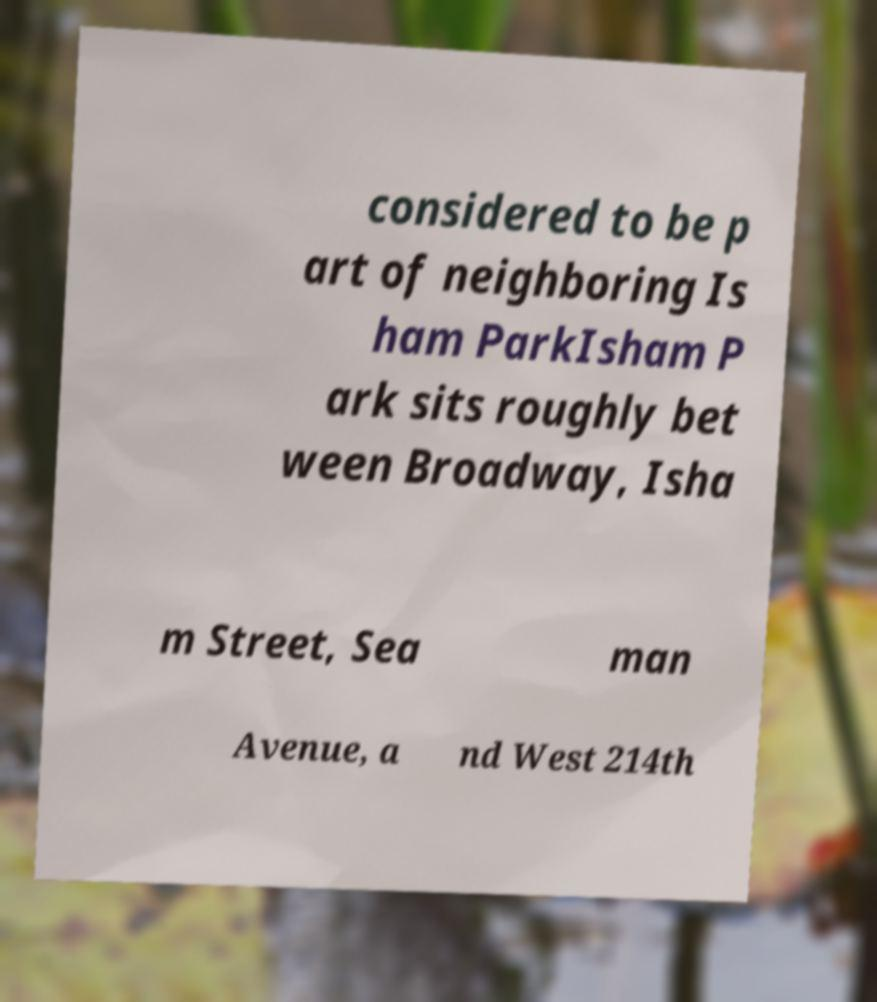There's text embedded in this image that I need extracted. Can you transcribe it verbatim? considered to be p art of neighboring Is ham ParkIsham P ark sits roughly bet ween Broadway, Isha m Street, Sea man Avenue, a nd West 214th 